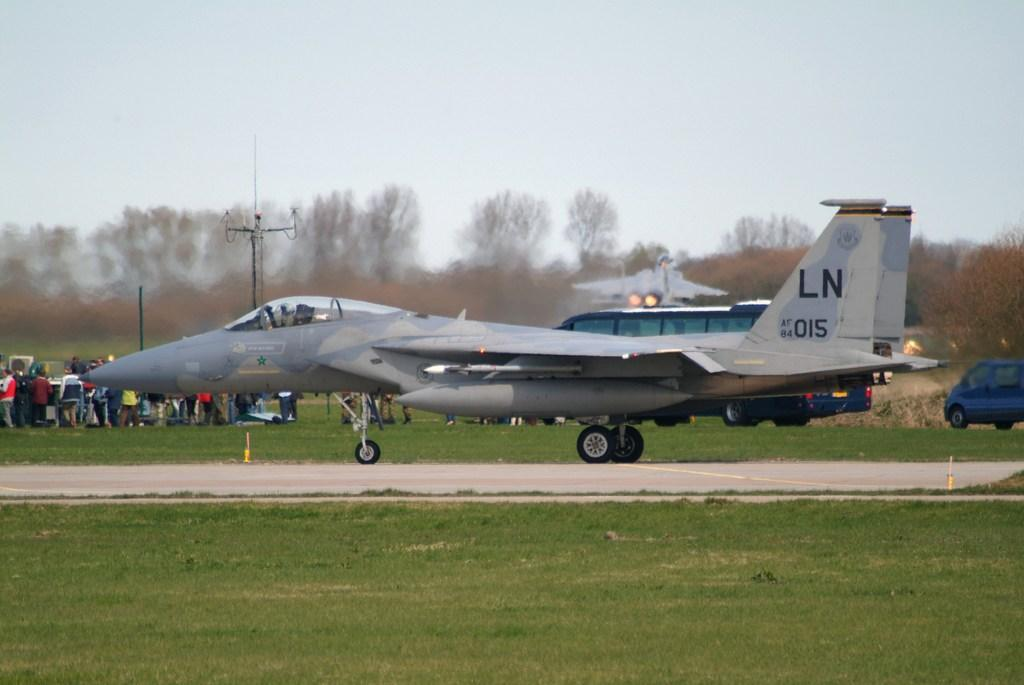Provide a one-sentence caption for the provided image. A display from the Air force and one of the aircraft is LN015. 